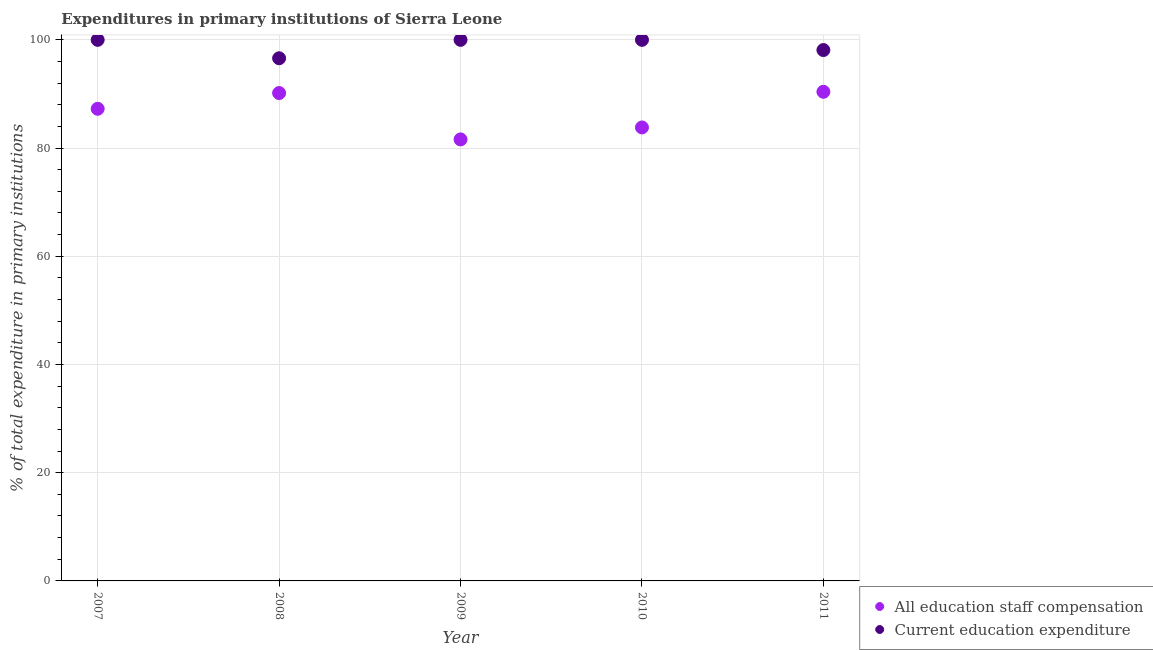What is the expenditure in staff compensation in 2010?
Make the answer very short. 83.81. Across all years, what is the minimum expenditure in education?
Provide a short and direct response. 96.6. In which year was the expenditure in staff compensation maximum?
Offer a terse response. 2011. What is the total expenditure in staff compensation in the graph?
Your answer should be very brief. 433.24. What is the difference between the expenditure in staff compensation in 2008 and that in 2009?
Provide a short and direct response. 8.57. What is the difference between the expenditure in education in 2011 and the expenditure in staff compensation in 2008?
Offer a terse response. 7.95. What is the average expenditure in staff compensation per year?
Your answer should be very brief. 86.65. In the year 2007, what is the difference between the expenditure in staff compensation and expenditure in education?
Give a very brief answer. -12.74. In how many years, is the expenditure in staff compensation greater than 76 %?
Provide a succinct answer. 5. What is the ratio of the expenditure in education in 2007 to that in 2008?
Offer a very short reply. 1.04. What is the difference between the highest and the lowest expenditure in staff compensation?
Your response must be concise. 8.8. Does the expenditure in staff compensation monotonically increase over the years?
Your answer should be compact. No. Is the expenditure in education strictly greater than the expenditure in staff compensation over the years?
Provide a short and direct response. Yes. Is the expenditure in staff compensation strictly less than the expenditure in education over the years?
Ensure brevity in your answer.  Yes. How many dotlines are there?
Offer a very short reply. 2. Are the values on the major ticks of Y-axis written in scientific E-notation?
Offer a terse response. No. Does the graph contain any zero values?
Offer a very short reply. No. How many legend labels are there?
Your answer should be very brief. 2. How are the legend labels stacked?
Your answer should be very brief. Vertical. What is the title of the graph?
Ensure brevity in your answer.  Expenditures in primary institutions of Sierra Leone. What is the label or title of the X-axis?
Give a very brief answer. Year. What is the label or title of the Y-axis?
Your answer should be compact. % of total expenditure in primary institutions. What is the % of total expenditure in primary institutions in All education staff compensation in 2007?
Make the answer very short. 87.26. What is the % of total expenditure in primary institutions of Current education expenditure in 2007?
Give a very brief answer. 100. What is the % of total expenditure in primary institutions in All education staff compensation in 2008?
Offer a very short reply. 90.17. What is the % of total expenditure in primary institutions in Current education expenditure in 2008?
Your answer should be very brief. 96.6. What is the % of total expenditure in primary institutions of All education staff compensation in 2009?
Ensure brevity in your answer.  81.6. What is the % of total expenditure in primary institutions of Current education expenditure in 2009?
Provide a short and direct response. 100. What is the % of total expenditure in primary institutions in All education staff compensation in 2010?
Provide a short and direct response. 83.81. What is the % of total expenditure in primary institutions in Current education expenditure in 2010?
Make the answer very short. 100. What is the % of total expenditure in primary institutions of All education staff compensation in 2011?
Provide a succinct answer. 90.4. What is the % of total expenditure in primary institutions in Current education expenditure in 2011?
Offer a terse response. 98.12. Across all years, what is the maximum % of total expenditure in primary institutions in All education staff compensation?
Give a very brief answer. 90.4. Across all years, what is the maximum % of total expenditure in primary institutions in Current education expenditure?
Your response must be concise. 100. Across all years, what is the minimum % of total expenditure in primary institutions of All education staff compensation?
Provide a short and direct response. 81.6. Across all years, what is the minimum % of total expenditure in primary institutions of Current education expenditure?
Give a very brief answer. 96.6. What is the total % of total expenditure in primary institutions in All education staff compensation in the graph?
Offer a very short reply. 433.24. What is the total % of total expenditure in primary institutions of Current education expenditure in the graph?
Provide a succinct answer. 494.71. What is the difference between the % of total expenditure in primary institutions of All education staff compensation in 2007 and that in 2008?
Provide a succinct answer. -2.91. What is the difference between the % of total expenditure in primary institutions of Current education expenditure in 2007 and that in 2008?
Keep it short and to the point. 3.4. What is the difference between the % of total expenditure in primary institutions in All education staff compensation in 2007 and that in 2009?
Your answer should be very brief. 5.66. What is the difference between the % of total expenditure in primary institutions of All education staff compensation in 2007 and that in 2010?
Give a very brief answer. 3.45. What is the difference between the % of total expenditure in primary institutions in All education staff compensation in 2007 and that in 2011?
Your answer should be very brief. -3.14. What is the difference between the % of total expenditure in primary institutions of Current education expenditure in 2007 and that in 2011?
Offer a very short reply. 1.88. What is the difference between the % of total expenditure in primary institutions of All education staff compensation in 2008 and that in 2009?
Keep it short and to the point. 8.57. What is the difference between the % of total expenditure in primary institutions of Current education expenditure in 2008 and that in 2009?
Provide a succinct answer. -3.4. What is the difference between the % of total expenditure in primary institutions of All education staff compensation in 2008 and that in 2010?
Your response must be concise. 6.36. What is the difference between the % of total expenditure in primary institutions in Current education expenditure in 2008 and that in 2010?
Your answer should be very brief. -3.4. What is the difference between the % of total expenditure in primary institutions of All education staff compensation in 2008 and that in 2011?
Offer a terse response. -0.23. What is the difference between the % of total expenditure in primary institutions of Current education expenditure in 2008 and that in 2011?
Provide a short and direct response. -1.52. What is the difference between the % of total expenditure in primary institutions of All education staff compensation in 2009 and that in 2010?
Your answer should be very brief. -2.21. What is the difference between the % of total expenditure in primary institutions of Current education expenditure in 2009 and that in 2010?
Offer a very short reply. 0. What is the difference between the % of total expenditure in primary institutions of All education staff compensation in 2009 and that in 2011?
Your response must be concise. -8.8. What is the difference between the % of total expenditure in primary institutions of Current education expenditure in 2009 and that in 2011?
Ensure brevity in your answer.  1.88. What is the difference between the % of total expenditure in primary institutions in All education staff compensation in 2010 and that in 2011?
Ensure brevity in your answer.  -6.59. What is the difference between the % of total expenditure in primary institutions of Current education expenditure in 2010 and that in 2011?
Give a very brief answer. 1.88. What is the difference between the % of total expenditure in primary institutions in All education staff compensation in 2007 and the % of total expenditure in primary institutions in Current education expenditure in 2008?
Your answer should be very brief. -9.34. What is the difference between the % of total expenditure in primary institutions of All education staff compensation in 2007 and the % of total expenditure in primary institutions of Current education expenditure in 2009?
Ensure brevity in your answer.  -12.74. What is the difference between the % of total expenditure in primary institutions of All education staff compensation in 2007 and the % of total expenditure in primary institutions of Current education expenditure in 2010?
Offer a terse response. -12.74. What is the difference between the % of total expenditure in primary institutions in All education staff compensation in 2007 and the % of total expenditure in primary institutions in Current education expenditure in 2011?
Offer a terse response. -10.86. What is the difference between the % of total expenditure in primary institutions of All education staff compensation in 2008 and the % of total expenditure in primary institutions of Current education expenditure in 2009?
Your answer should be very brief. -9.83. What is the difference between the % of total expenditure in primary institutions of All education staff compensation in 2008 and the % of total expenditure in primary institutions of Current education expenditure in 2010?
Provide a short and direct response. -9.83. What is the difference between the % of total expenditure in primary institutions of All education staff compensation in 2008 and the % of total expenditure in primary institutions of Current education expenditure in 2011?
Your answer should be compact. -7.95. What is the difference between the % of total expenditure in primary institutions in All education staff compensation in 2009 and the % of total expenditure in primary institutions in Current education expenditure in 2010?
Offer a terse response. -18.4. What is the difference between the % of total expenditure in primary institutions in All education staff compensation in 2009 and the % of total expenditure in primary institutions in Current education expenditure in 2011?
Your answer should be compact. -16.51. What is the difference between the % of total expenditure in primary institutions of All education staff compensation in 2010 and the % of total expenditure in primary institutions of Current education expenditure in 2011?
Your answer should be compact. -14.3. What is the average % of total expenditure in primary institutions in All education staff compensation per year?
Provide a succinct answer. 86.65. What is the average % of total expenditure in primary institutions in Current education expenditure per year?
Make the answer very short. 98.94. In the year 2007, what is the difference between the % of total expenditure in primary institutions in All education staff compensation and % of total expenditure in primary institutions in Current education expenditure?
Give a very brief answer. -12.74. In the year 2008, what is the difference between the % of total expenditure in primary institutions of All education staff compensation and % of total expenditure in primary institutions of Current education expenditure?
Give a very brief answer. -6.43. In the year 2009, what is the difference between the % of total expenditure in primary institutions of All education staff compensation and % of total expenditure in primary institutions of Current education expenditure?
Keep it short and to the point. -18.4. In the year 2010, what is the difference between the % of total expenditure in primary institutions in All education staff compensation and % of total expenditure in primary institutions in Current education expenditure?
Your response must be concise. -16.19. In the year 2011, what is the difference between the % of total expenditure in primary institutions of All education staff compensation and % of total expenditure in primary institutions of Current education expenditure?
Your answer should be compact. -7.71. What is the ratio of the % of total expenditure in primary institutions in Current education expenditure in 2007 to that in 2008?
Provide a short and direct response. 1.04. What is the ratio of the % of total expenditure in primary institutions of All education staff compensation in 2007 to that in 2009?
Your response must be concise. 1.07. What is the ratio of the % of total expenditure in primary institutions in Current education expenditure in 2007 to that in 2009?
Provide a succinct answer. 1. What is the ratio of the % of total expenditure in primary institutions in All education staff compensation in 2007 to that in 2010?
Offer a very short reply. 1.04. What is the ratio of the % of total expenditure in primary institutions of All education staff compensation in 2007 to that in 2011?
Ensure brevity in your answer.  0.97. What is the ratio of the % of total expenditure in primary institutions of Current education expenditure in 2007 to that in 2011?
Provide a succinct answer. 1.02. What is the ratio of the % of total expenditure in primary institutions of All education staff compensation in 2008 to that in 2009?
Your answer should be very brief. 1.1. What is the ratio of the % of total expenditure in primary institutions in Current education expenditure in 2008 to that in 2009?
Your answer should be compact. 0.97. What is the ratio of the % of total expenditure in primary institutions of All education staff compensation in 2008 to that in 2010?
Ensure brevity in your answer.  1.08. What is the ratio of the % of total expenditure in primary institutions in Current education expenditure in 2008 to that in 2010?
Provide a succinct answer. 0.97. What is the ratio of the % of total expenditure in primary institutions of Current education expenditure in 2008 to that in 2011?
Provide a succinct answer. 0.98. What is the ratio of the % of total expenditure in primary institutions of All education staff compensation in 2009 to that in 2010?
Your answer should be compact. 0.97. What is the ratio of the % of total expenditure in primary institutions in All education staff compensation in 2009 to that in 2011?
Offer a terse response. 0.9. What is the ratio of the % of total expenditure in primary institutions of Current education expenditure in 2009 to that in 2011?
Provide a short and direct response. 1.02. What is the ratio of the % of total expenditure in primary institutions of All education staff compensation in 2010 to that in 2011?
Provide a short and direct response. 0.93. What is the ratio of the % of total expenditure in primary institutions in Current education expenditure in 2010 to that in 2011?
Make the answer very short. 1.02. What is the difference between the highest and the second highest % of total expenditure in primary institutions of All education staff compensation?
Give a very brief answer. 0.23. What is the difference between the highest and the lowest % of total expenditure in primary institutions of All education staff compensation?
Make the answer very short. 8.8. What is the difference between the highest and the lowest % of total expenditure in primary institutions of Current education expenditure?
Offer a very short reply. 3.4. 